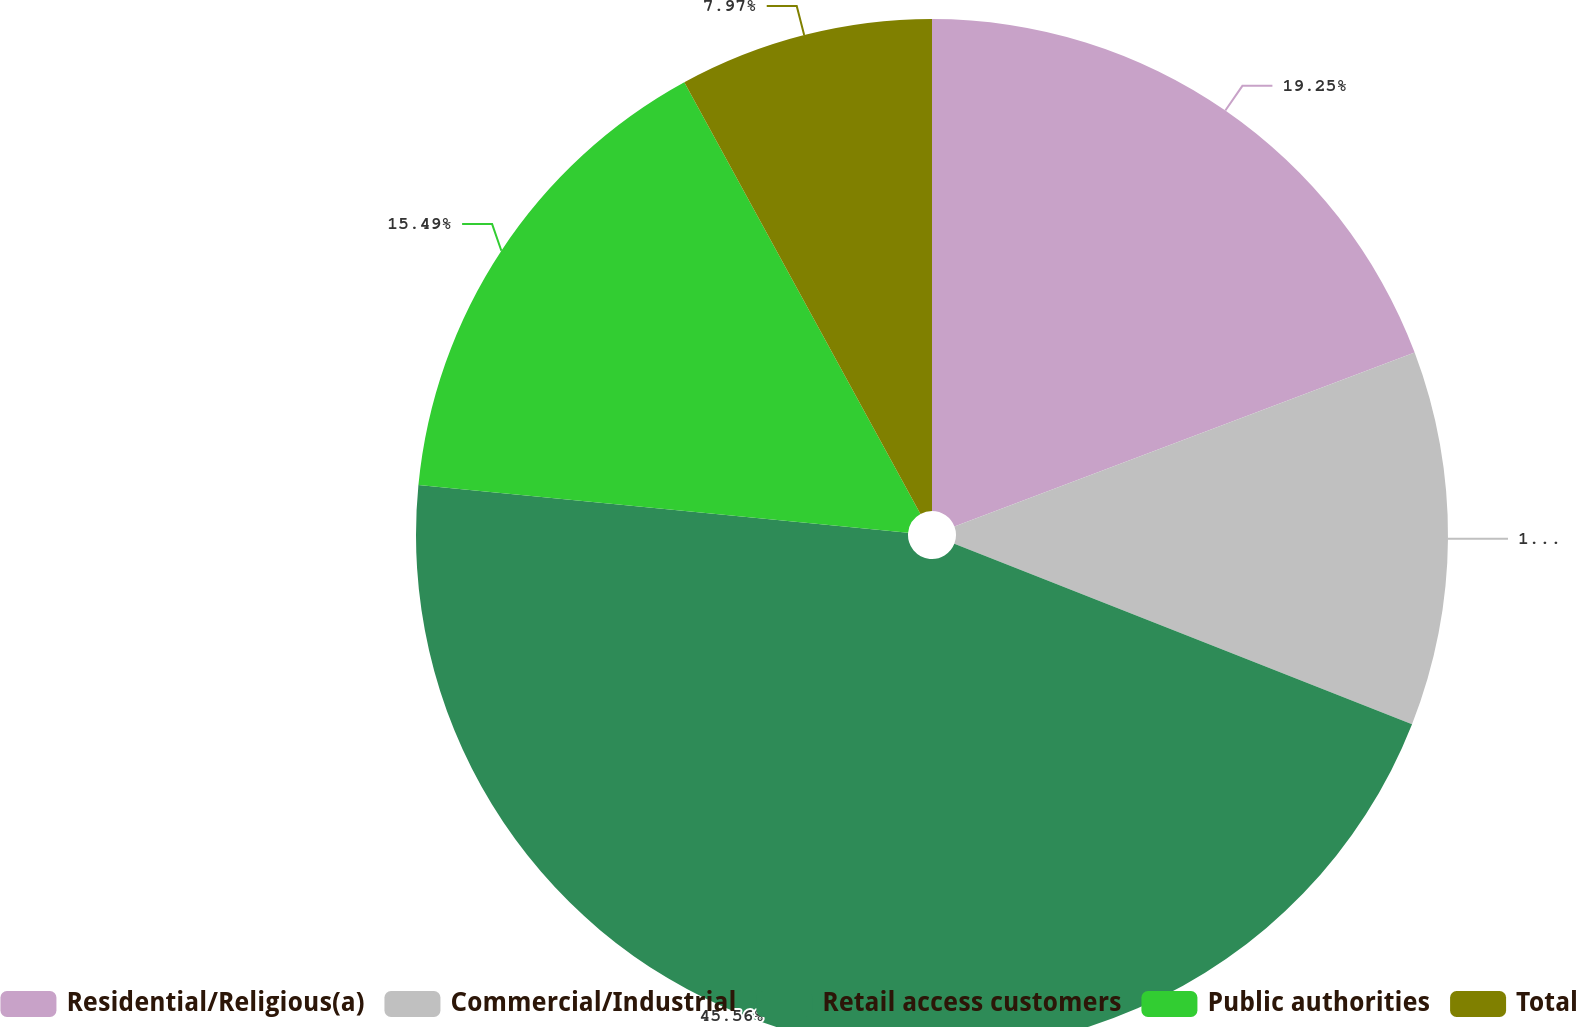<chart> <loc_0><loc_0><loc_500><loc_500><pie_chart><fcel>Residential/Religious(a)<fcel>Commercial/Industrial<fcel>Retail access customers<fcel>Public authorities<fcel>Total<nl><fcel>19.25%<fcel>11.73%<fcel>45.57%<fcel>15.49%<fcel>7.97%<nl></chart> 